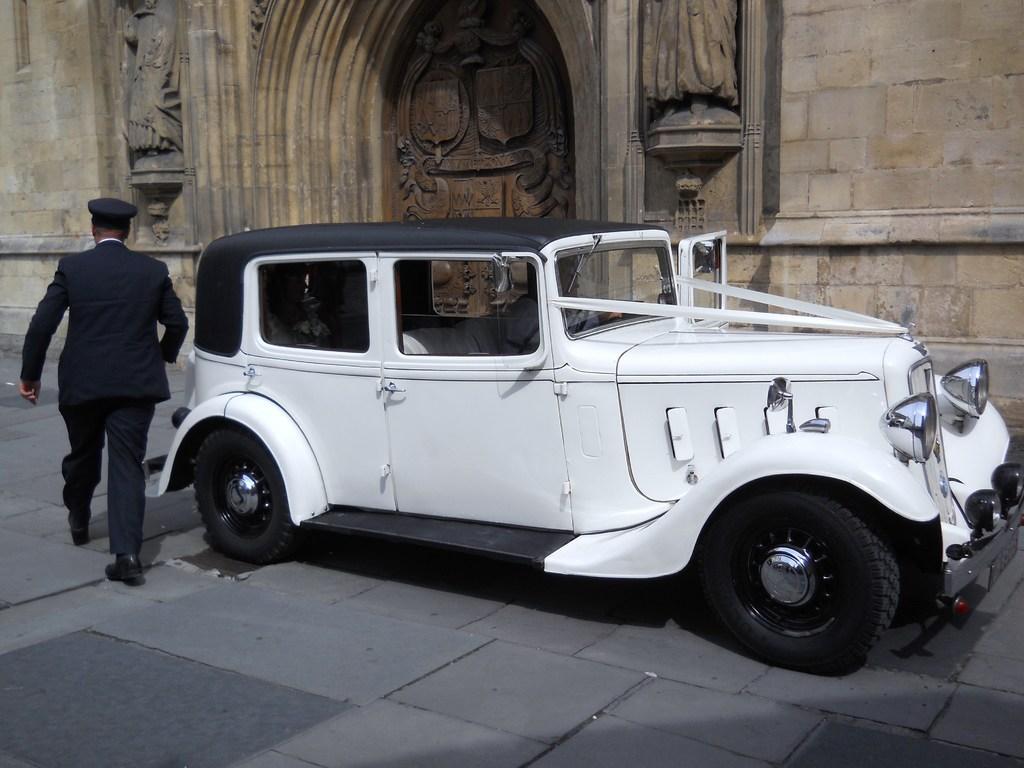Could you give a brief overview of what you see in this image? This white car is highlighted in this picture. Inside this white a human is sitting. This person is walking as there is a leg movement. This is a stone carving. 